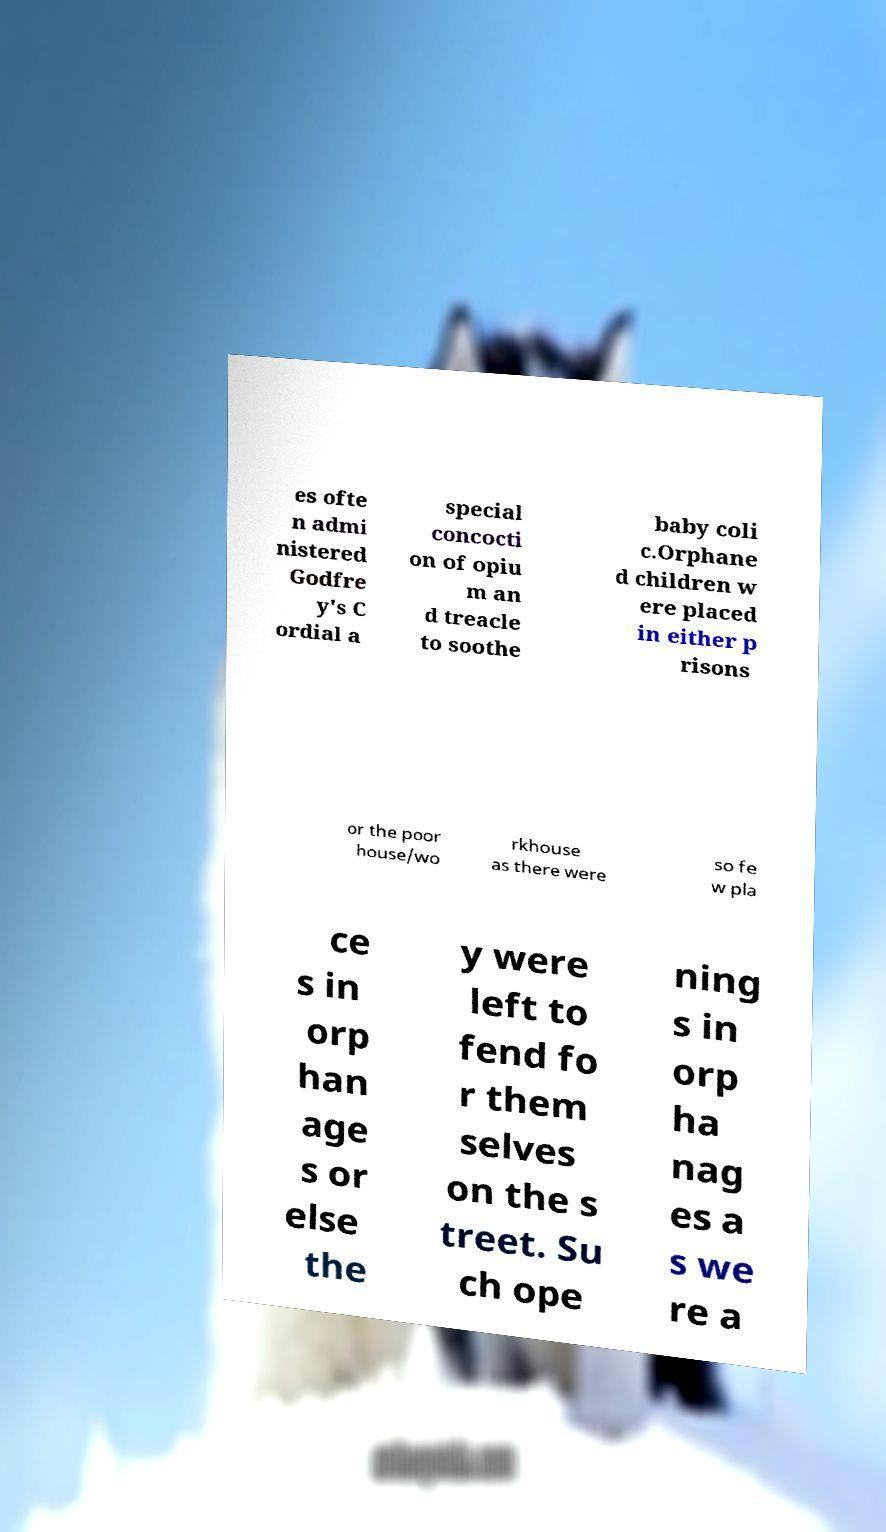There's text embedded in this image that I need extracted. Can you transcribe it verbatim? es ofte n admi nistered Godfre y's C ordial a special concocti on of opiu m an d treacle to soothe baby coli c.Orphane d children w ere placed in either p risons or the poor house/wo rkhouse as there were so fe w pla ce s in orp han age s or else the y were left to fend fo r them selves on the s treet. Su ch ope ning s in orp ha nag es a s we re a 